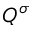<formula> <loc_0><loc_0><loc_500><loc_500>Q ^ { \sigma }</formula> 